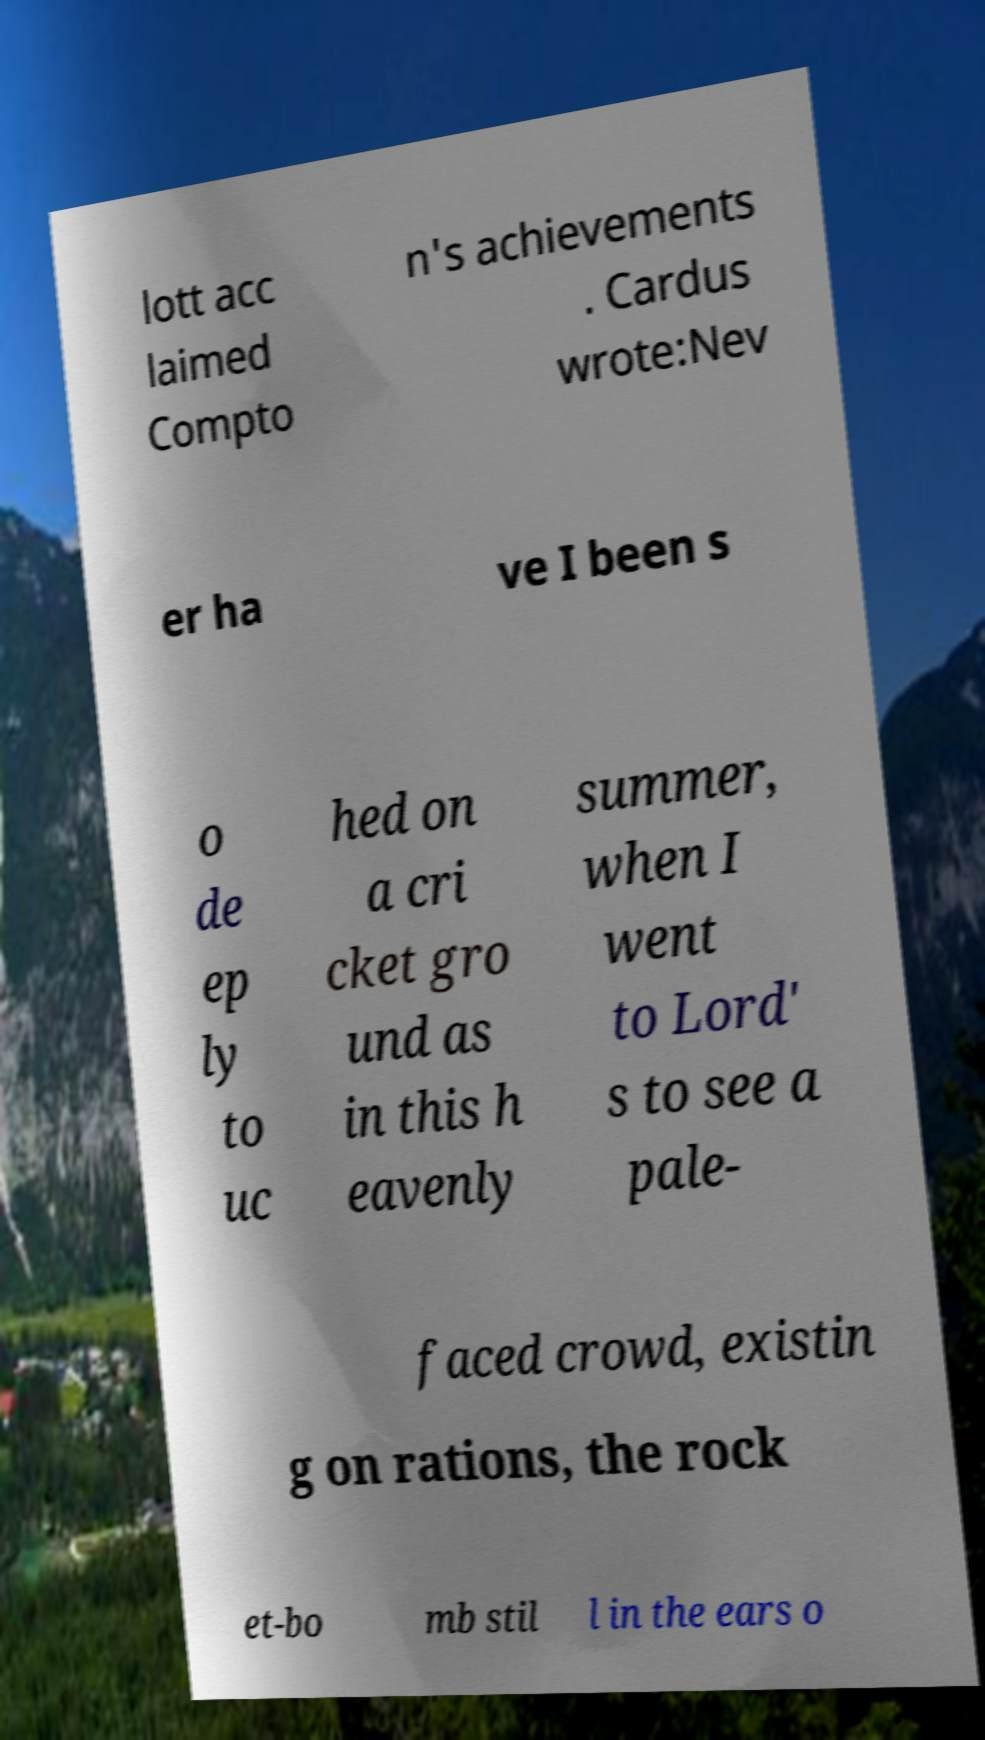Please read and relay the text visible in this image. What does it say? lott acc laimed Compto n's achievements . Cardus wrote:Nev er ha ve I been s o de ep ly to uc hed on a cri cket gro und as in this h eavenly summer, when I went to Lord' s to see a pale- faced crowd, existin g on rations, the rock et-bo mb stil l in the ears o 